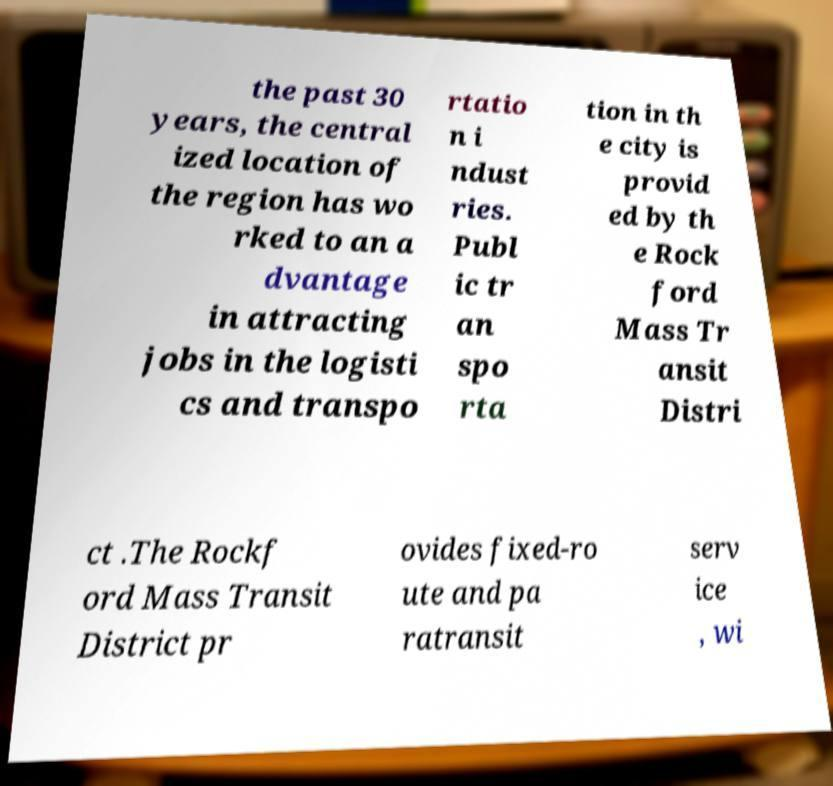Could you extract and type out the text from this image? the past 30 years, the central ized location of the region has wo rked to an a dvantage in attracting jobs in the logisti cs and transpo rtatio n i ndust ries. Publ ic tr an spo rta tion in th e city is provid ed by th e Rock ford Mass Tr ansit Distri ct .The Rockf ord Mass Transit District pr ovides fixed-ro ute and pa ratransit serv ice , wi 